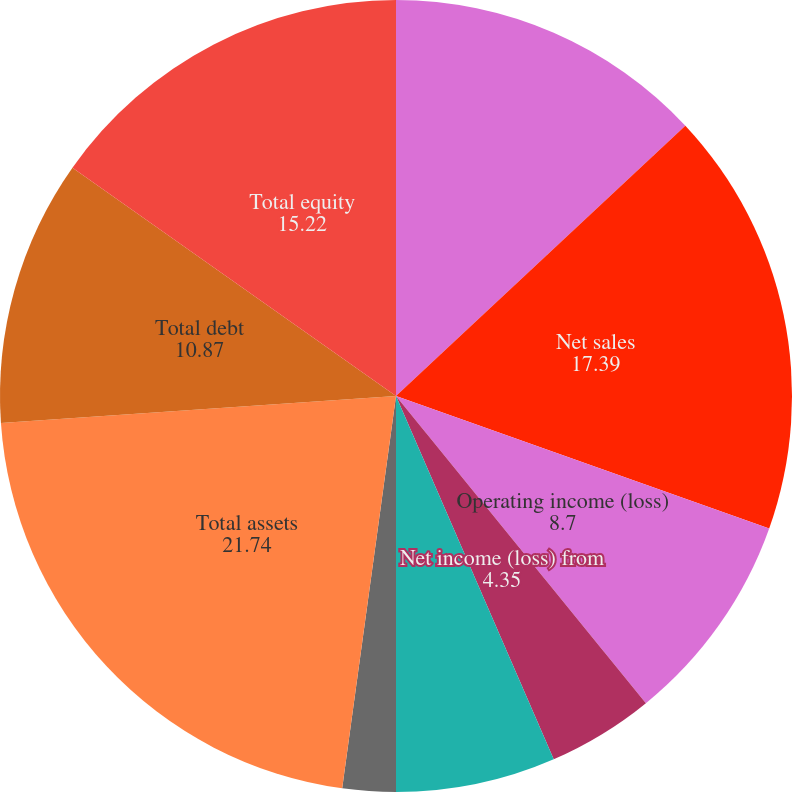<chart> <loc_0><loc_0><loc_500><loc_500><pie_chart><fcel>In millions except per-share<fcel>Net sales<fcel>Operating income (loss)<fcel>Net income (loss) from<fcel>Earnings (loss) per ordinary<fcel>Weighted average shares<fcel>Cash dividends declared and<fcel>Total assets<fcel>Total debt<fcel>Total equity<nl><fcel>13.04%<fcel>17.39%<fcel>8.7%<fcel>4.35%<fcel>0.0%<fcel>6.52%<fcel>2.17%<fcel>21.74%<fcel>10.87%<fcel>15.22%<nl></chart> 